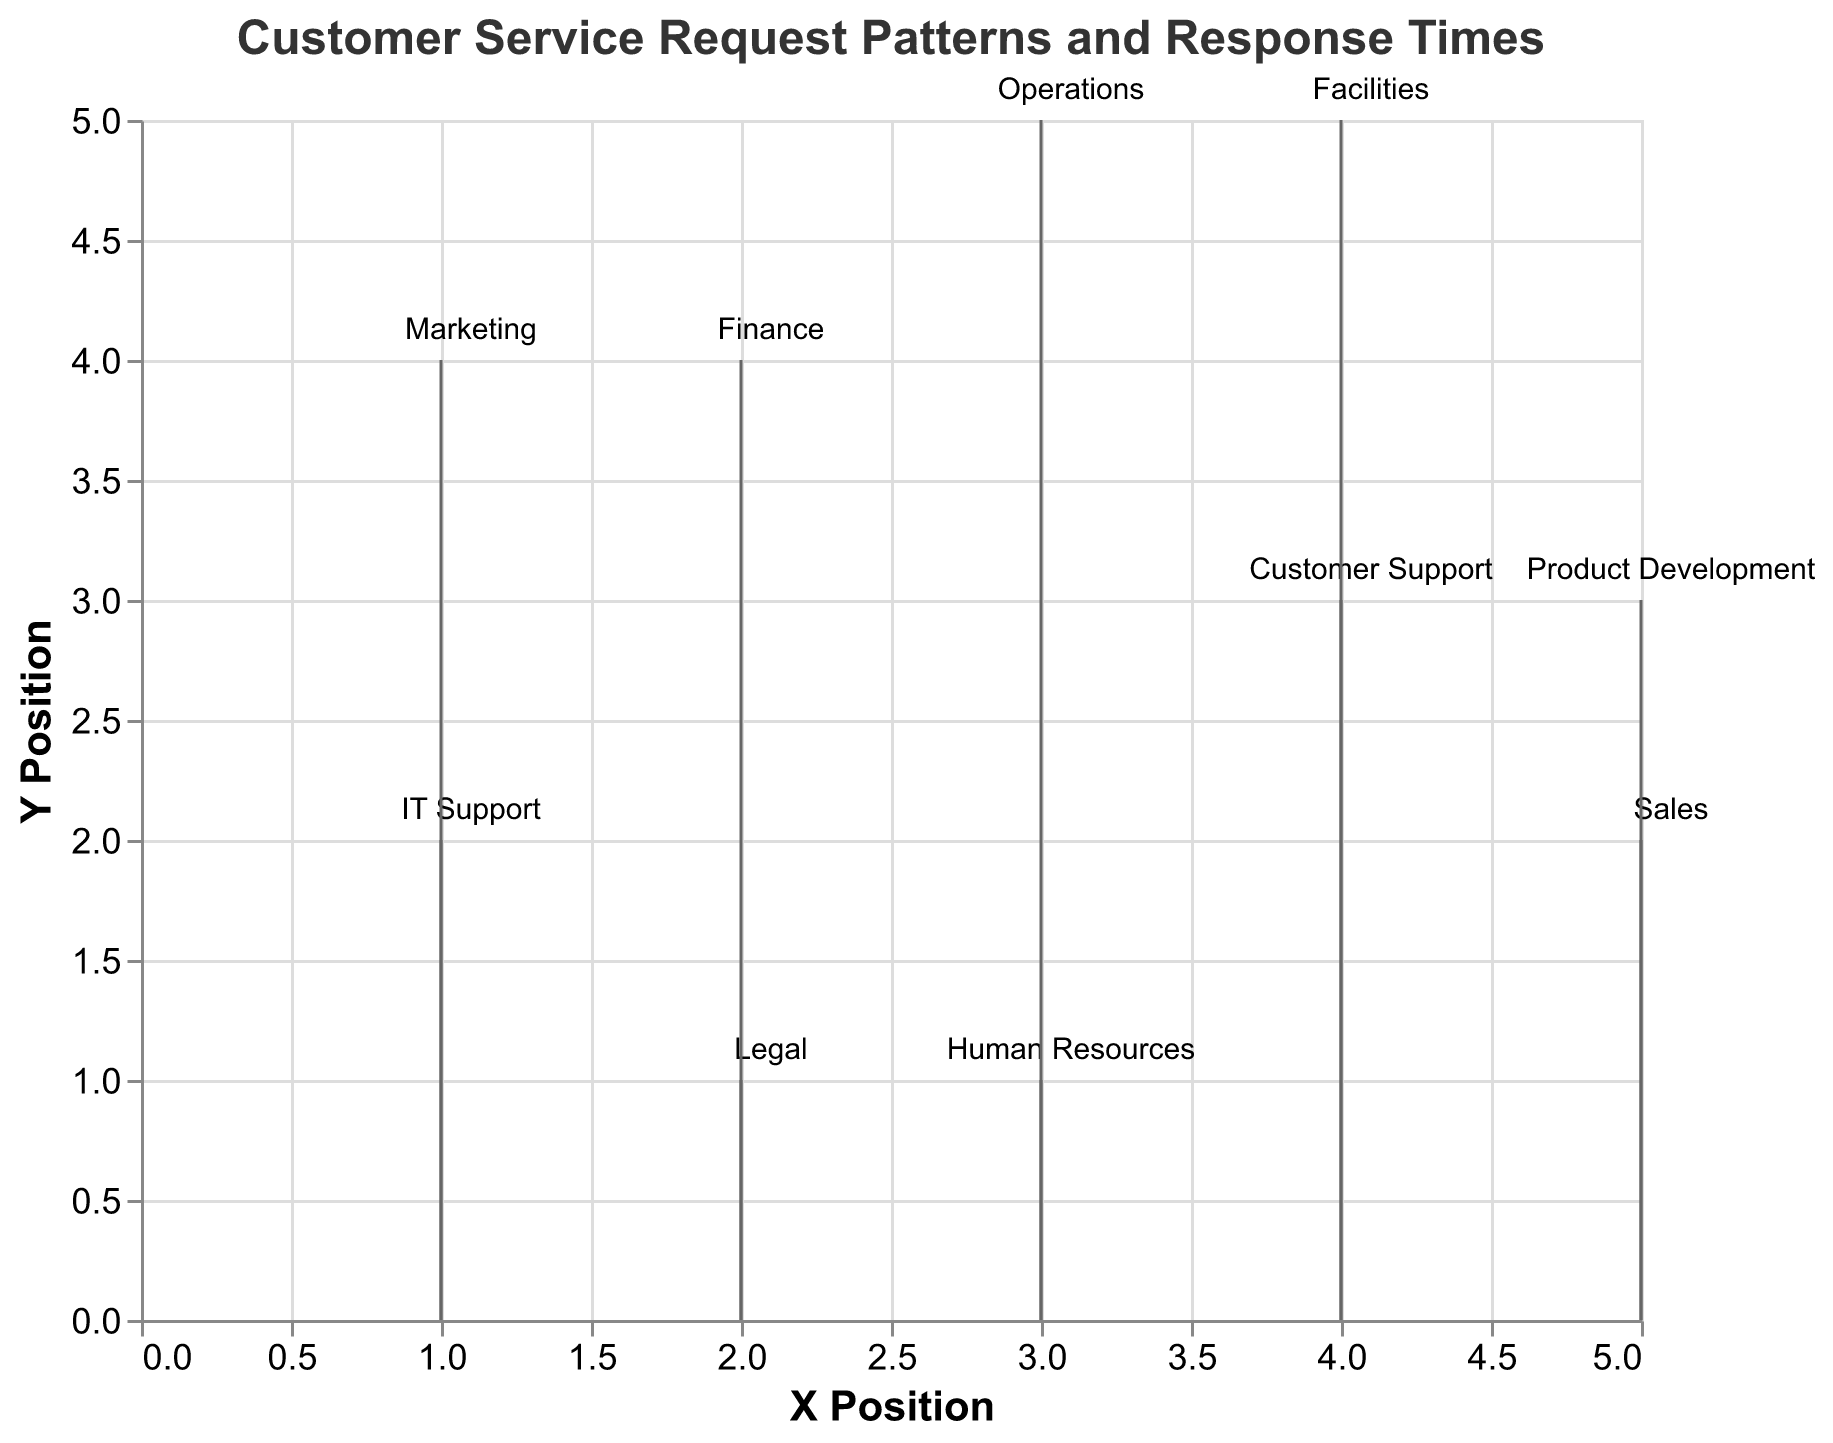What is the title of the plot? The title is displayed at the top center of the plot in bold, indicating the main focus of the visualization.
Answer: Customer Service Request Patterns and Response Times How many departments have been analyzed in the plot? By counting the unique points on the plot, each representing a different department, you can determine the number.
Answer: 10 Which department has the highest request volume and what is it? Look for the largest point on the plot, as the size of the points is proportional to request volume.
Answer: Customer Support, 200 Which department has the longest response time? Identify the department with the longest arrow since the length of the lines represents response time.
Answer: Legal, 6.2 hours What are the coordinates of the IT Support department in the plot? Find the point labeled "IT Support" on the plot and note its (X, Y) position.
Answer: (1, 2) Calculate the average response time of all departments shown in the plot. Sum all the response times and divide by the number of departments: (4.5 + 3.2 + 5.1 + 2.8 + 4.7 + 3.9 + 3.5 + 6.2 + 4.3 + 5.5) / 10.
Answer: 4.37 hours Which two departments are closest to each other in terms of their positions? Measure the Euclidean distance between pairs of departments by comparing their (X, Y) coordinates. The closest pair has the smallest distance.
Answer: Human Resources and Sales Compare the request volumes of IT Support and Product Development. Which department has a higher request volume and by how much? Identify the request volumes of these departments and subtract the smaller from the larger value.
Answer: IT Support by 40 Which department has the fastest average response time? Identify the department with the smallest arrow since shorter arrows represent faster response times.
Answer: Customer Support, 2.8 hours What is the total request volume of all departments combined? Sum the request volumes of all departments: 150 + 80 + 100 + 200 + 120 + 90 + 70 + 40 + 60 + 110.
Answer: 1020 